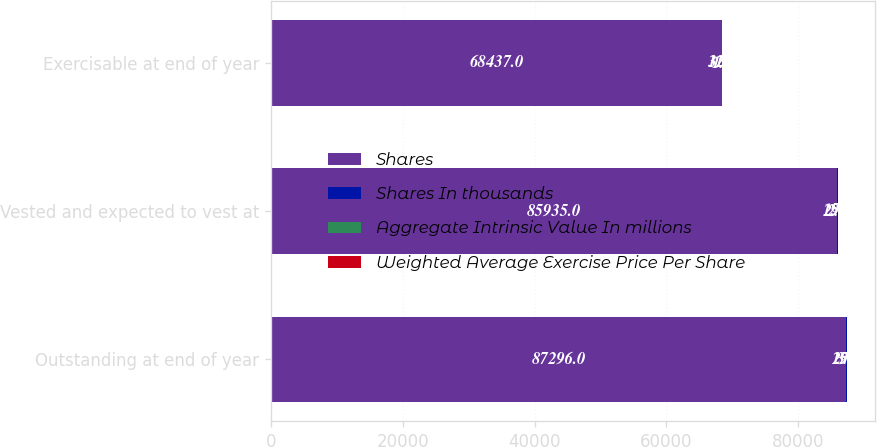Convert chart to OTSL. <chart><loc_0><loc_0><loc_500><loc_500><stacked_bar_chart><ecel><fcel>Outstanding at end of year<fcel>Vested and expected to vest at<fcel>Exercisable at end of year<nl><fcel>Shares<fcel>87296<fcel>85935<fcel>68437<nl><fcel>Shares In thousands<fcel>29<fcel>29<fcel>31<nl><fcel>Aggregate Intrinsic Value In millions<fcel>3<fcel>2.9<fcel>1.9<nl><fcel>Weighted Average Exercise Price Per Share<fcel>15<fcel>15<fcel>12<nl></chart> 